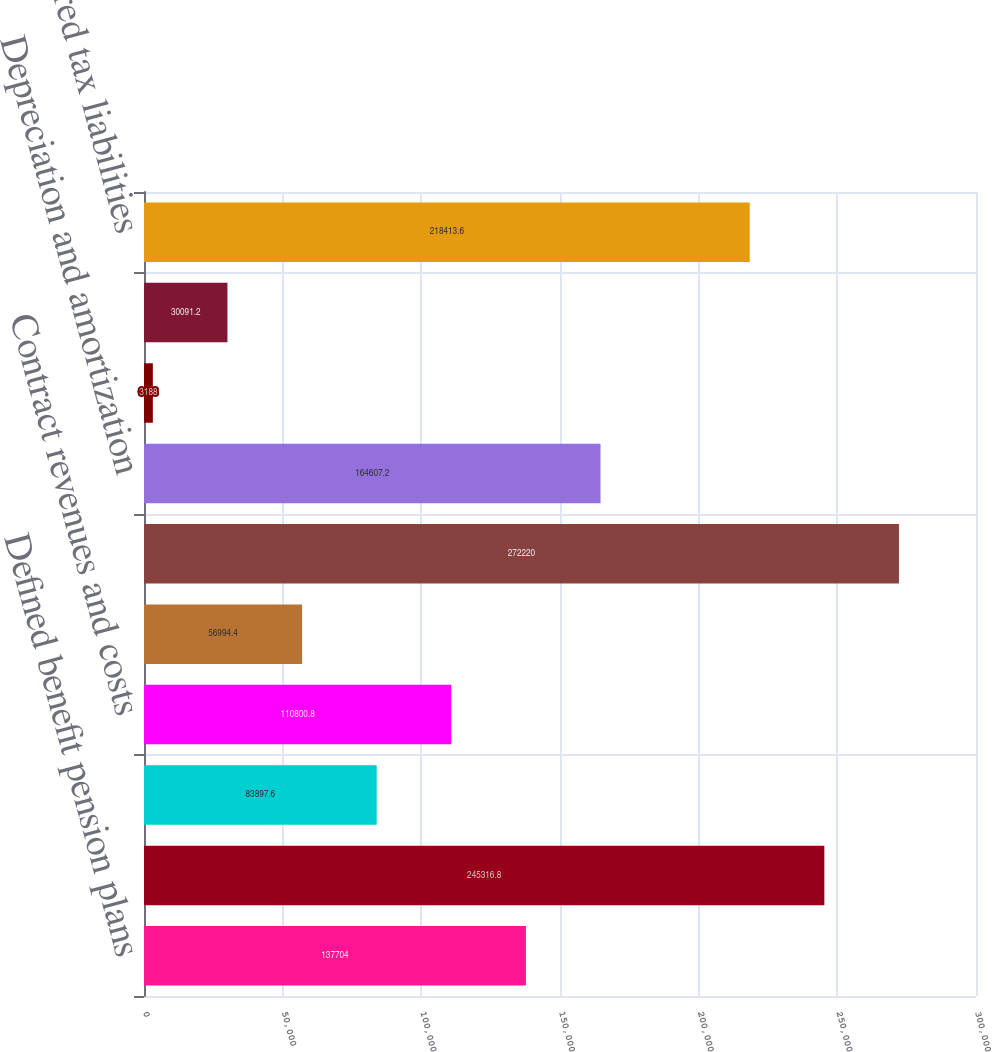<chart> <loc_0><loc_0><loc_500><loc_500><bar_chart><fcel>Defined benefit pension plans<fcel>Other employee benefit plans<fcel>Self-insurance programs<fcel>Contract revenues and costs<fcel>Other<fcel>Gross deferred tax assets<fcel>Depreciation and amortization<fcel>Residual US tax on unremitted<fcel>Other net<fcel>Gross deferred tax liabilities<nl><fcel>137704<fcel>245317<fcel>83897.6<fcel>110801<fcel>56994.4<fcel>272220<fcel>164607<fcel>3188<fcel>30091.2<fcel>218414<nl></chart> 